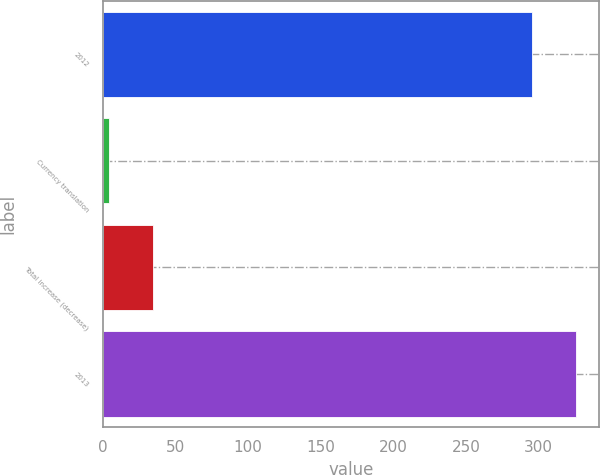Convert chart to OTSL. <chart><loc_0><loc_0><loc_500><loc_500><bar_chart><fcel>2012<fcel>Currency translation<fcel>Total increase (decrease)<fcel>2013<nl><fcel>295.3<fcel>4<fcel>34.29<fcel>325.59<nl></chart> 